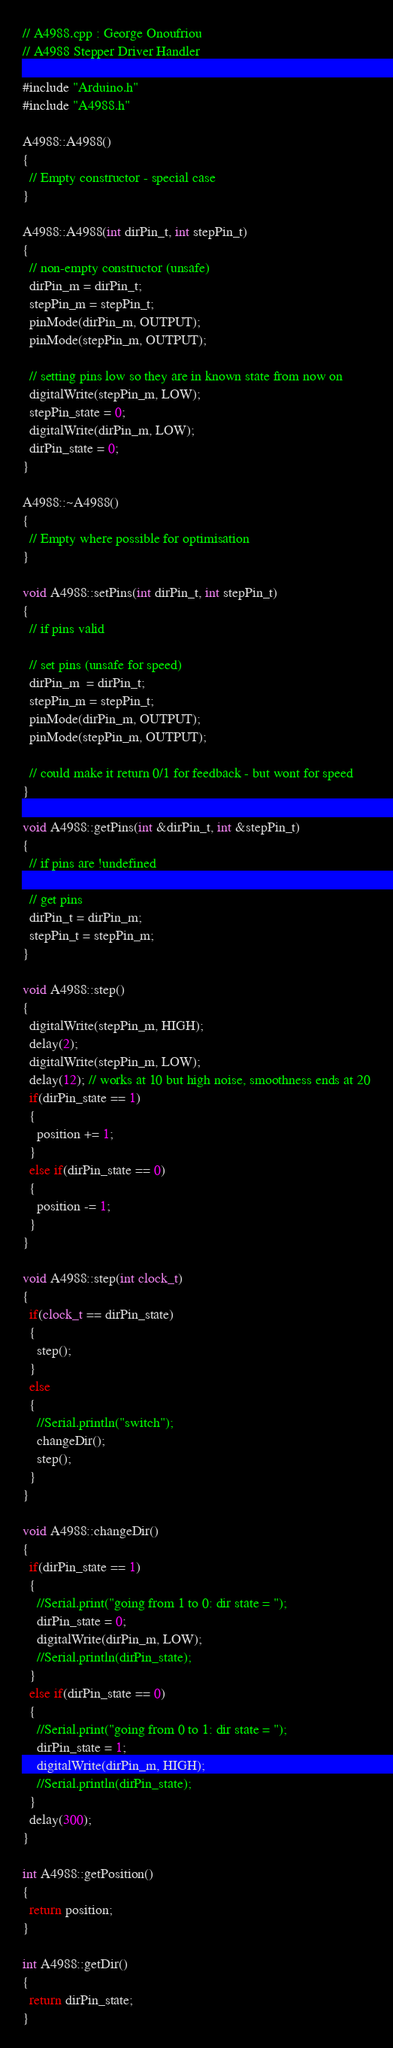Convert code to text. <code><loc_0><loc_0><loc_500><loc_500><_C++_>// A4988.cpp : George Onoufriou
// A4988 Stepper Driver Handler

#include "Arduino.h"
#include "A4988.h"

A4988::A4988()
{
  // Empty constructor - special case
}

A4988::A4988(int dirPin_t, int stepPin_t)
{
  // non-empty constructor (unsafe)
  dirPin_m = dirPin_t;
  stepPin_m = stepPin_t;
  pinMode(dirPin_m, OUTPUT);
  pinMode(stepPin_m, OUTPUT);

  // setting pins low so they are in known state from now on
  digitalWrite(stepPin_m, LOW);
  stepPin_state = 0;
  digitalWrite(dirPin_m, LOW);
  dirPin_state = 0;
}

A4988::~A4988()
{
  // Empty where possible for optimisation
}

void A4988::setPins(int dirPin_t, int stepPin_t)
{
  // if pins valid

  // set pins (unsafe for speed)
  dirPin_m  = dirPin_t;
  stepPin_m = stepPin_t;
  pinMode(dirPin_m, OUTPUT);
  pinMode(stepPin_m, OUTPUT);

  // could make it return 0/1 for feedback - but wont for speed
}

void A4988::getPins(int &dirPin_t, int &stepPin_t)
{
  // if pins are !undefined

  // get pins
  dirPin_t = dirPin_m;
  stepPin_t = stepPin_m;
}

void A4988::step()
{
  digitalWrite(stepPin_m, HIGH);
  delay(2);
  digitalWrite(stepPin_m, LOW);
  delay(12); // works at 10 but high noise, smoothness ends at 20
  if(dirPin_state == 1)
  {
    position += 1;
  }
  else if(dirPin_state == 0)
  {
    position -= 1;
  }
}

void A4988::step(int clock_t)
{
  if(clock_t == dirPin_state)
  {
    step();
  }
  else
  {
    //Serial.println("switch");
    changeDir();
    step();
  }
}

void A4988::changeDir()
{
  if(dirPin_state == 1)
  {
    //Serial.print("going from 1 to 0: dir state = ");
    dirPin_state = 0;
    digitalWrite(dirPin_m, LOW);
    //Serial.println(dirPin_state);
  }
  else if(dirPin_state == 0)
  {
    //Serial.print("going from 0 to 1: dir state = ");
    dirPin_state = 1;
    digitalWrite(dirPin_m, HIGH);
    //Serial.println(dirPin_state);
  }
  delay(300);
}

int A4988::getPosition()
{
  return position;
}

int A4988::getDir()
{
  return dirPin_state;
}
</code> 